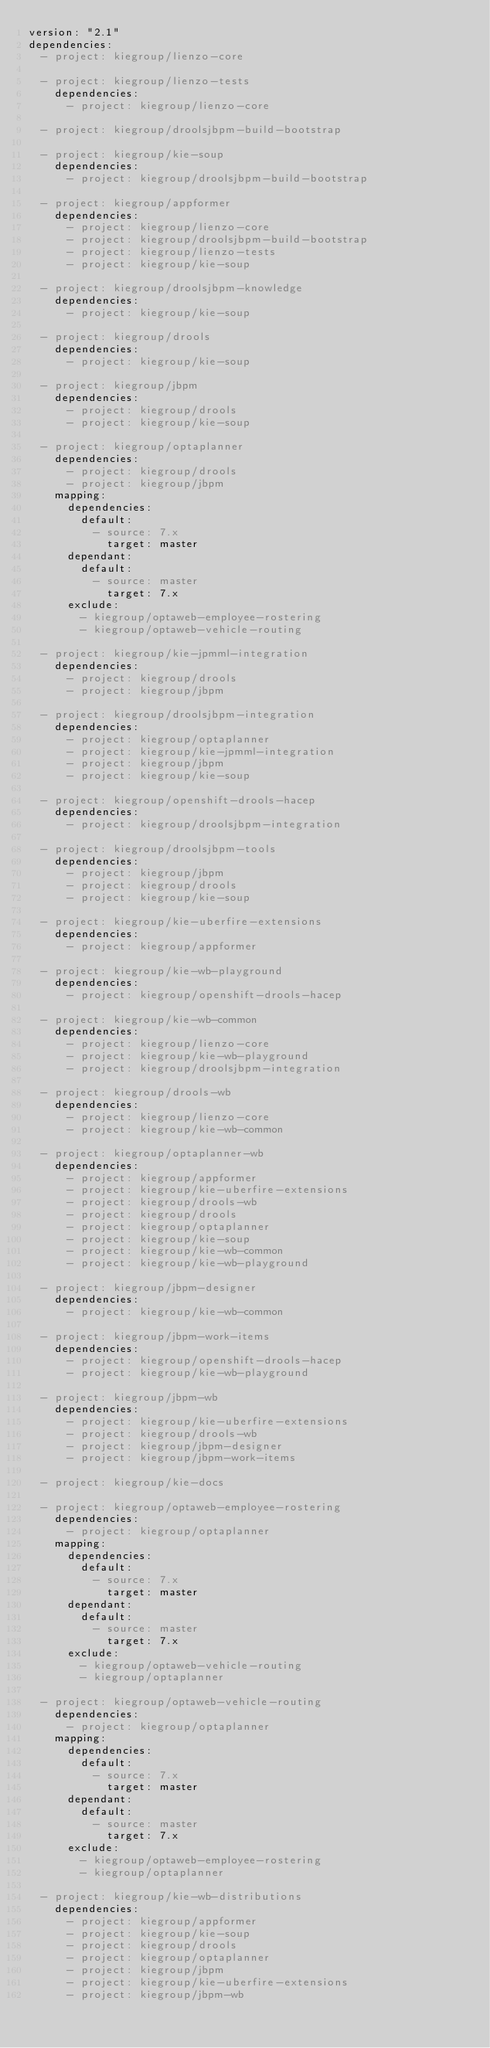Convert code to text. <code><loc_0><loc_0><loc_500><loc_500><_YAML_>version: "2.1"
dependencies:
  - project: kiegroup/lienzo-core

  - project: kiegroup/lienzo-tests
    dependencies:
      - project: kiegroup/lienzo-core

  - project: kiegroup/droolsjbpm-build-bootstrap

  - project: kiegroup/kie-soup
    dependencies:
      - project: kiegroup/droolsjbpm-build-bootstrap

  - project: kiegroup/appformer
    dependencies:
      - project: kiegroup/lienzo-core
      - project: kiegroup/droolsjbpm-build-bootstrap
      - project: kiegroup/lienzo-tests
      - project: kiegroup/kie-soup

  - project: kiegroup/droolsjbpm-knowledge
    dependencies:
      - project: kiegroup/kie-soup

  - project: kiegroup/drools
    dependencies:
      - project: kiegroup/kie-soup

  - project: kiegroup/jbpm
    dependencies:
      - project: kiegroup/drools
      - project: kiegroup/kie-soup

  - project: kiegroup/optaplanner
    dependencies:
      - project: kiegroup/drools
      - project: kiegroup/jbpm
    mapping:
      dependencies:
        default:
          - source: 7.x
            target: master
      dependant:
        default:
          - source: master
            target: 7.x
      exclude:
        - kiegroup/optaweb-employee-rostering
        - kiegroup/optaweb-vehicle-routing

  - project: kiegroup/kie-jpmml-integration
    dependencies:
      - project: kiegroup/drools
      - project: kiegroup/jbpm

  - project: kiegroup/droolsjbpm-integration
    dependencies:
      - project: kiegroup/optaplanner
      - project: kiegroup/kie-jpmml-integration
      - project: kiegroup/jbpm
      - project: kiegroup/kie-soup

  - project: kiegroup/openshift-drools-hacep
    dependencies:
      - project: kiegroup/droolsjbpm-integration

  - project: kiegroup/droolsjbpm-tools
    dependencies:
      - project: kiegroup/jbpm
      - project: kiegroup/drools
      - project: kiegroup/kie-soup

  - project: kiegroup/kie-uberfire-extensions
    dependencies:
      - project: kiegroup/appformer

  - project: kiegroup/kie-wb-playground
    dependencies:
      - project: kiegroup/openshift-drools-hacep

  - project: kiegroup/kie-wb-common
    dependencies:
      - project: kiegroup/lienzo-core
      - project: kiegroup/kie-wb-playground
      - project: kiegroup/droolsjbpm-integration

  - project: kiegroup/drools-wb
    dependencies:
      - project: kiegroup/lienzo-core
      - project: kiegroup/kie-wb-common

  - project: kiegroup/optaplanner-wb
    dependencies:
      - project: kiegroup/appformer
      - project: kiegroup/kie-uberfire-extensions
      - project: kiegroup/drools-wb
      - project: kiegroup/drools
      - project: kiegroup/optaplanner
      - project: kiegroup/kie-soup
      - project: kiegroup/kie-wb-common
      - project: kiegroup/kie-wb-playground

  - project: kiegroup/jbpm-designer
    dependencies:
      - project: kiegroup/kie-wb-common

  - project: kiegroup/jbpm-work-items
    dependencies:
      - project: kiegroup/openshift-drools-hacep
      - project: kiegroup/kie-wb-playground

  - project: kiegroup/jbpm-wb
    dependencies:
      - project: kiegroup/kie-uberfire-extensions
      - project: kiegroup/drools-wb
      - project: kiegroup/jbpm-designer
      - project: kiegroup/jbpm-work-items

  - project: kiegroup/kie-docs

  - project: kiegroup/optaweb-employee-rostering
    dependencies:
      - project: kiegroup/optaplanner
    mapping:
      dependencies:
        default:
          - source: 7.x
            target: master
      dependant:
        default:
          - source: master
            target: 7.x
      exclude:
        - kiegroup/optaweb-vehicle-routing
        - kiegroup/optaplanner

  - project: kiegroup/optaweb-vehicle-routing
    dependencies:
      - project: kiegroup/optaplanner
    mapping:
      dependencies:
        default:
          - source: 7.x
            target: master
      dependant:
        default:
          - source: master
            target: 7.x
      exclude:
        - kiegroup/optaweb-employee-rostering
        - kiegroup/optaplanner

  - project: kiegroup/kie-wb-distributions
    dependencies:
      - project: kiegroup/appformer
      - project: kiegroup/kie-soup
      - project: kiegroup/drools
      - project: kiegroup/optaplanner
      - project: kiegroup/jbpm
      - project: kiegroup/kie-uberfire-extensions
      - project: kiegroup/jbpm-wb
</code> 